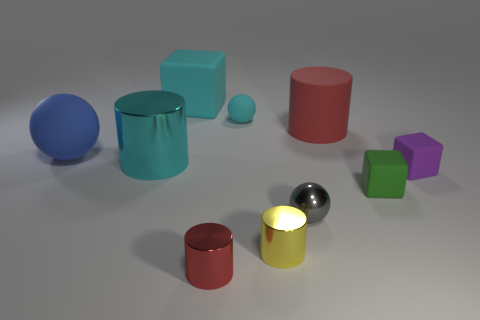Subtract all spheres. How many objects are left? 7 Add 8 small cyan objects. How many small cyan objects are left? 9 Add 5 cylinders. How many cylinders exist? 9 Subtract 1 cyan blocks. How many objects are left? 9 Subtract all large gray metal cylinders. Subtract all big metallic cylinders. How many objects are left? 9 